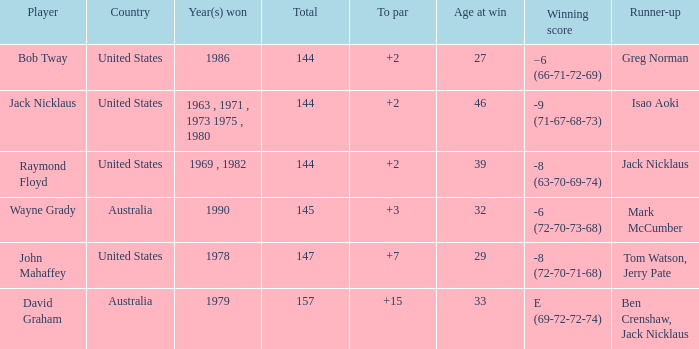Parse the full table. {'header': ['Player', 'Country', 'Year(s) won', 'Total', 'To par', 'Age at win', 'Winning score', 'Runner-up'], 'rows': [['Bob Tway', 'United States', '1986', '144', '+2', '27', '−6 (66-71-72-69)', 'Greg Norman'], ['Jack Nicklaus', 'United States', '1963 , 1971 , 1973 1975 , 1980', '144', '+2', '46', '-9 (71-67-68-73)', 'Isao Aoki'], ['Raymond Floyd', 'United States', '1969 , 1982', '144', '+2', '39', '-8 (63-70-69-74)', 'Jack Nicklaus'], ['Wayne Grady', 'Australia', '1990', '145', '+3', '32', '-6 (72-70-73-68)', 'Mark McCumber'], ['John Mahaffey', 'United States', '1978', '147', '+7', '29', '-8 (72-70-71-68)', 'Tom Watson, Jerry Pate'], ['David Graham', 'Australia', '1979', '157', '+15', '33', 'E (69-72-72-74)', 'Ben Crenshaw, Jack Nicklaus']]} What was the average round score of the player who won in 1978? 147.0. 